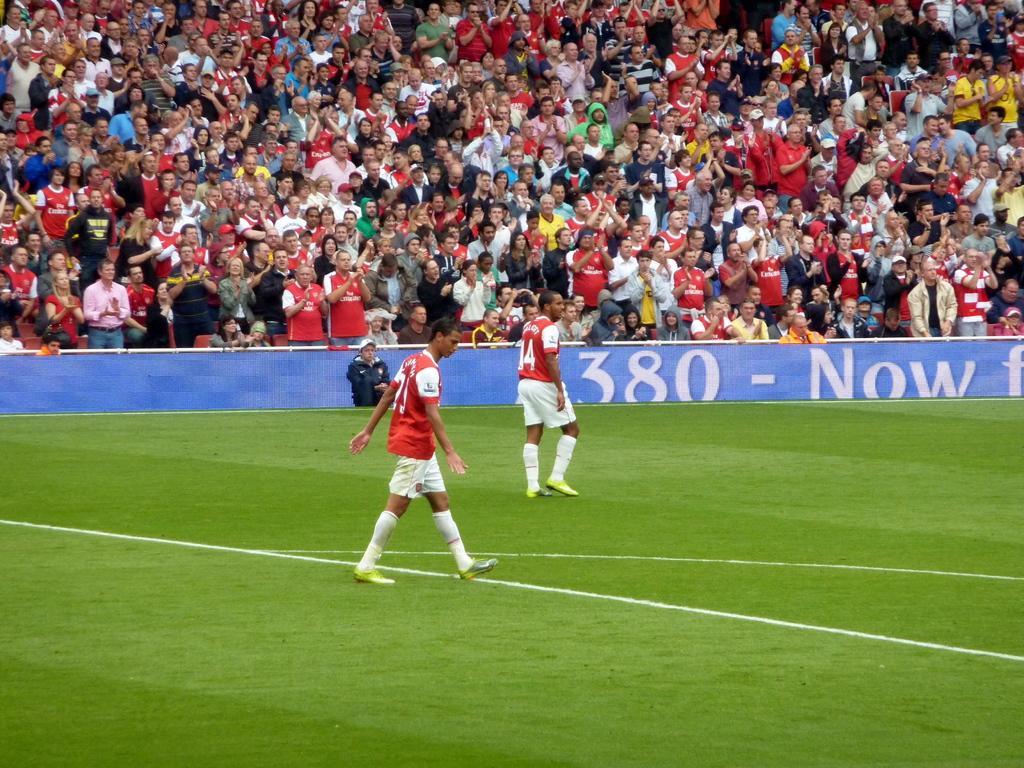Can you describe this image briefly? In this image I can see two people are on the ground. These people are wearing the red and white color dresses. To the side of these people I can see one person in -front of the blue color board. In the background I can see the group of people with the different color dresses and I can see few people with the caps. 